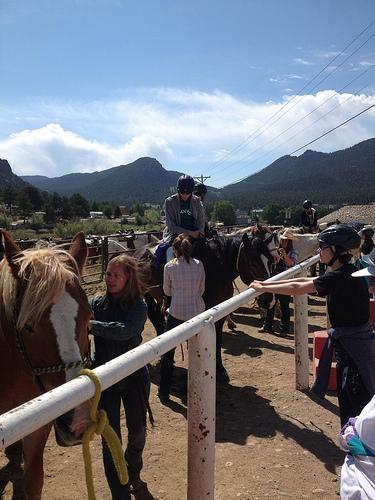How many horses with blonde manes are there?
Give a very brief answer. 1. How many people are riding horses?
Give a very brief answer. 2. 